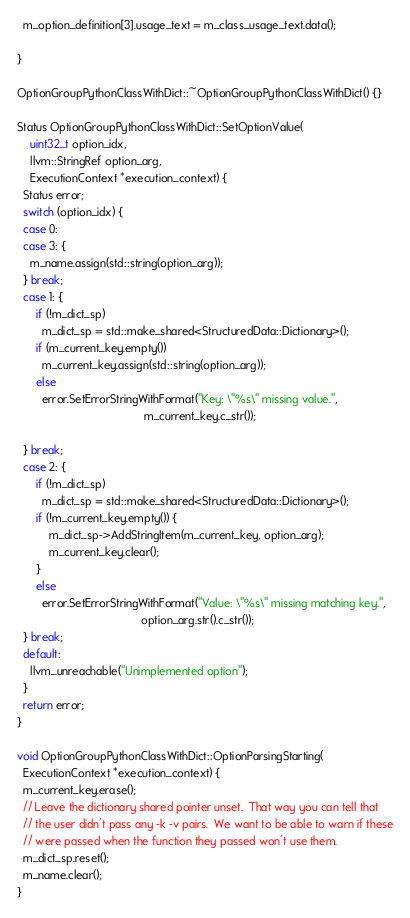<code> <loc_0><loc_0><loc_500><loc_500><_C++_>  m_option_definition[3].usage_text = m_class_usage_text.data();

}

OptionGroupPythonClassWithDict::~OptionGroupPythonClassWithDict() {}

Status OptionGroupPythonClassWithDict::SetOptionValue(
    uint32_t option_idx,
    llvm::StringRef option_arg,
    ExecutionContext *execution_context) {
  Status error;
  switch (option_idx) {
  case 0:
  case 3: {
    m_name.assign(std::string(option_arg));
  } break;
  case 1: {
      if (!m_dict_sp)
        m_dict_sp = std::make_shared<StructuredData::Dictionary>();
      if (m_current_key.empty())
        m_current_key.assign(std::string(option_arg));
      else
        error.SetErrorStringWithFormat("Key: \"%s\" missing value.",
                                        m_current_key.c_str());
    
  } break;
  case 2: {
      if (!m_dict_sp)
        m_dict_sp = std::make_shared<StructuredData::Dictionary>();
      if (!m_current_key.empty()) {
          m_dict_sp->AddStringItem(m_current_key, option_arg);
          m_current_key.clear();
      }
      else
        error.SetErrorStringWithFormat("Value: \"%s\" missing matching key.",
                                       option_arg.str().c_str());
  } break;
  default:
    llvm_unreachable("Unimplemented option");
  }
  return error;
}

void OptionGroupPythonClassWithDict::OptionParsingStarting(
  ExecutionContext *execution_context) {
  m_current_key.erase();
  // Leave the dictionary shared pointer unset.  That way you can tell that
  // the user didn't pass any -k -v pairs.  We want to be able to warn if these
  // were passed when the function they passed won't use them.
  m_dict_sp.reset();
  m_name.clear();
}
</code> 